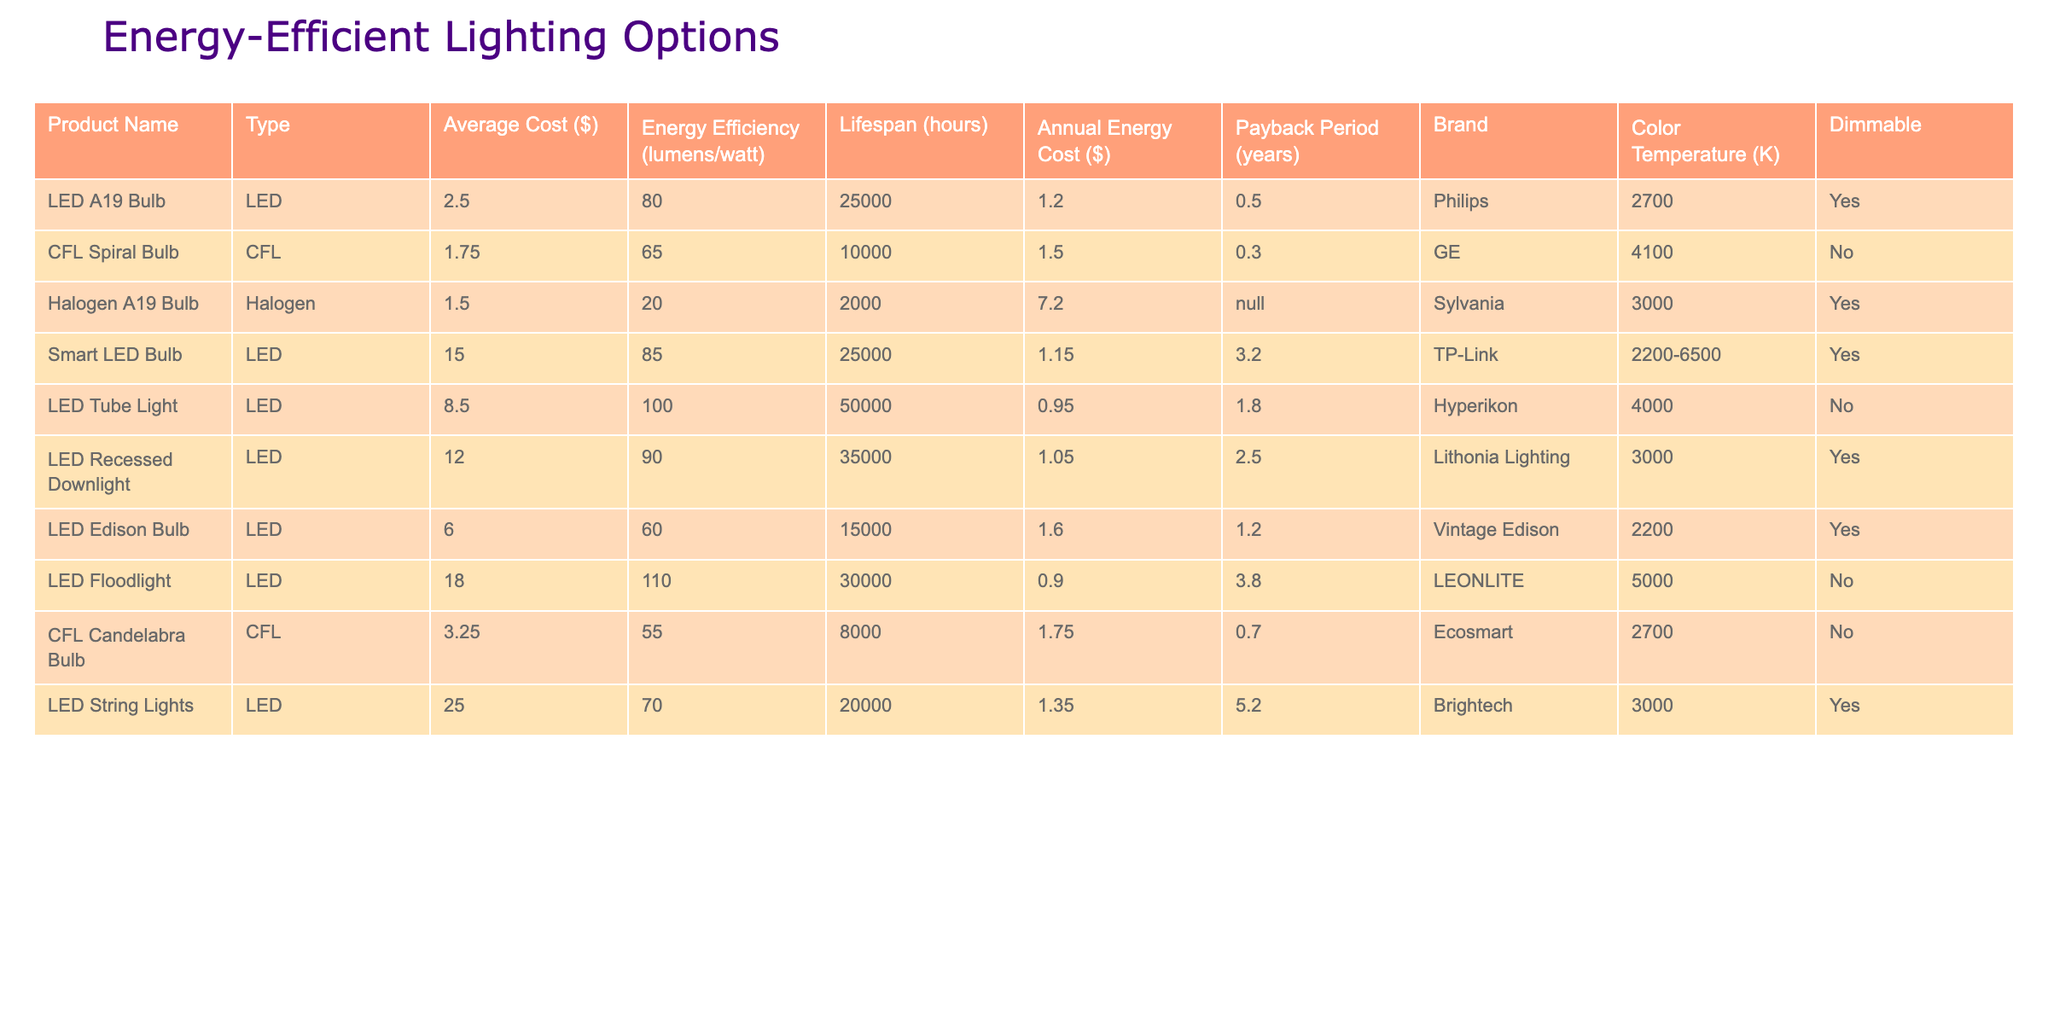What is the average cost of LED bulbs in the table? The LED bulbs are LED A19 Bulb ($2.50), Smart LED Bulb ($15.00), LED Tube Light ($8.50), LED Recessed Downlight ($12.00), LED Edison Bulb ($6.00), LED Floodlight ($18.00), and LED String Lights ($25.00). The total cost is 2.50 + 15 + 8.50 + 12 + 6 + 18 + 25 = 87.00, and there are 7 LED products, so the average is 87.00 / 7 = 12.43.
Answer: 12.43 Which bulb has the longest lifespan? The LED Tube Light has a lifespan of 50,000 hours, which is longer than any other product listed in the table.
Answer: LED Tube Light What is the total annual energy cost for all CFL bulbs? There are two CFL bulbs: CFL Spiral Bulb with an annual energy cost of $1.50 and CFL Candelabra Bulb at $1.75. Adding them together gives 1.50 + 1.75 = 3.25.
Answer: 3.25 How many products are dimmable? The products that are dimmable are LED A19 Bulb, Smart LED Bulb, LED Recessed Downlight, LED Edison Bulb, and LED String Lights, which totals 5 products.
Answer: 5 Is the average energy efficiency of LED bulbs higher than CFL bulbs? The average energy efficiency for LED bulbs (85.14) is calculated as follows: (80 + 85 + 100 + 90 + 60 + 110 + 70) / 7 = 85.14. For CFL bulbs (60), it's (65 + 55) / 2 = 60. Since 85.14 > 60, the statement is true.
Answer: Yes Which product has the highest payback period? The product with the highest payback period is LED String Lights at 5.2 years, compared to all others.
Answer: LED String Lights Is there a product with a payback period of less than one year? A payback period of less than one year is considered short-term. The LED Tube Light has a payback period of 1.8 years and LED A19 Bulb has a payback period of 0.5 years, which indicates there are products with shorter payback periods.
Answer: Yes What is the energy efficiency difference between the most and least efficient products? The most efficient product is LED Floodlight at 110 lumens/watt, and the least efficient product is Halogen A19 Bulb at 20 lumens/watt. The difference is 110 - 20 = 90 lumens/watt.
Answer: 90 What is the total average cost of all products listed? The average cost is found by summing all listed prices: (2.50 + 1.75 + 1.50 + 15 + 8.50 + 12 + 6 + 18 + 3.25 + 25) = 94.50 with a total of 10 products, so 94.50 / 10 = 9.45.
Answer: 9.45 Which type of bulb has the lowest annual energy cost? The LED Tube Light has the lowest annual energy cost at $0.95, which is lower than any other product.
Answer: LED Tube Light 